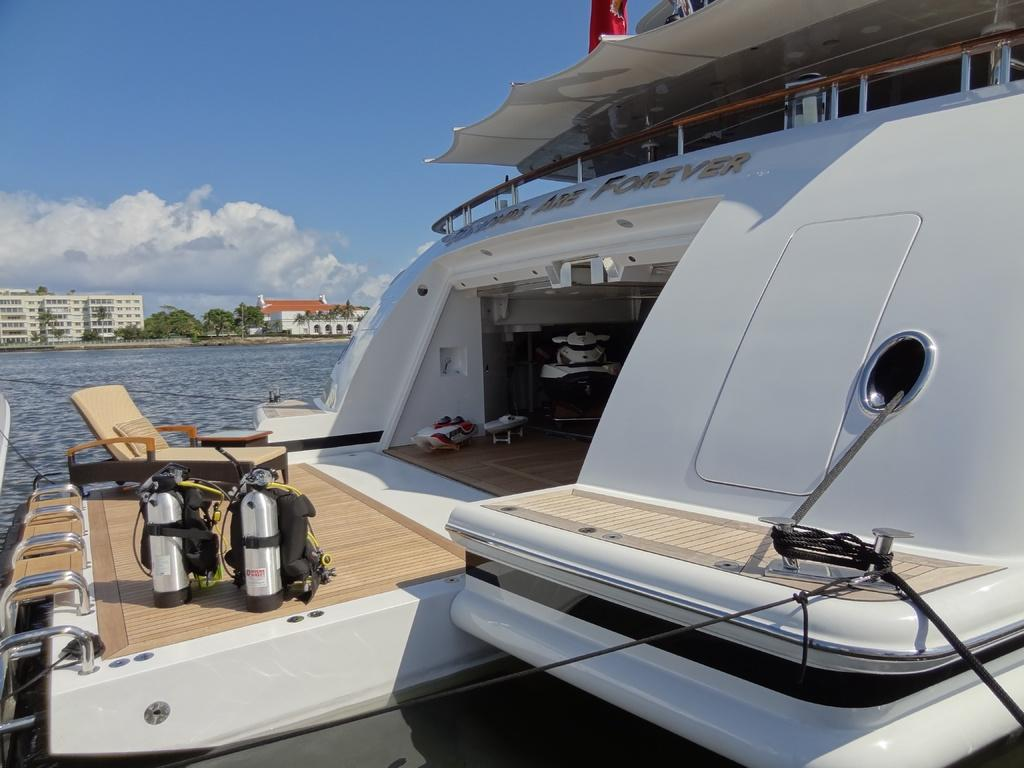What type of vehicle is in the image? There is a white color ship in the image. What is visible in the background of the image? Water, buildings, and trees are visible in the background of the image. What is the color of the sky in the image? The sky is blue in the image. How many balls are being juggled by the sun in the image? There is no sun or balls present in the image; it features a white color ship and a blue sky. 